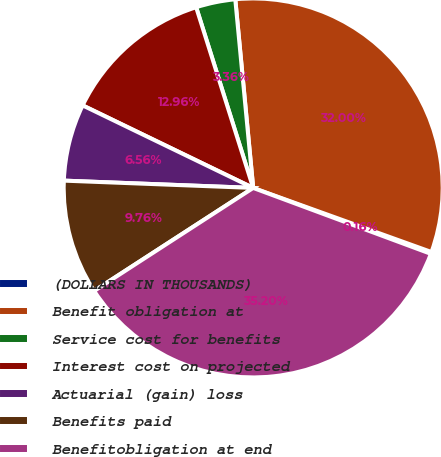Convert chart to OTSL. <chart><loc_0><loc_0><loc_500><loc_500><pie_chart><fcel>(DOLLARS IN THOUSANDS)<fcel>Benefit obligation at<fcel>Service cost for benefits<fcel>Interest cost on projected<fcel>Actuarial (gain) loss<fcel>Benefits paid<fcel>Benefitobligation at end<nl><fcel>0.16%<fcel>32.0%<fcel>3.36%<fcel>12.96%<fcel>6.56%<fcel>9.76%<fcel>35.2%<nl></chart> 